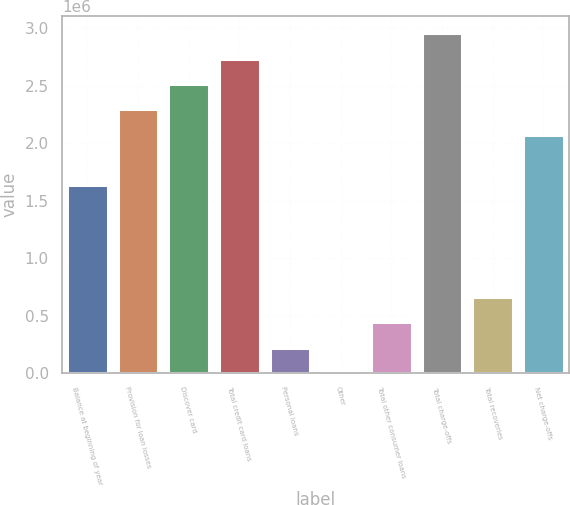Convert chart to OTSL. <chart><loc_0><loc_0><loc_500><loc_500><bar_chart><fcel>Balance at beginning of year<fcel>Provision for loan losses<fcel>Discover card<fcel>Total credit card loans<fcel>Personal loans<fcel>Other<fcel>Total other consumer loans<fcel>Total charge-offs<fcel>Total recoveries<fcel>Net charge-offs<nl><fcel>1.63229e+06<fcel>2.2941e+06<fcel>2.5147e+06<fcel>2.7353e+06<fcel>220627<fcel>25<fcel>441228<fcel>2.9559e+06<fcel>661830<fcel>2.07349e+06<nl></chart> 